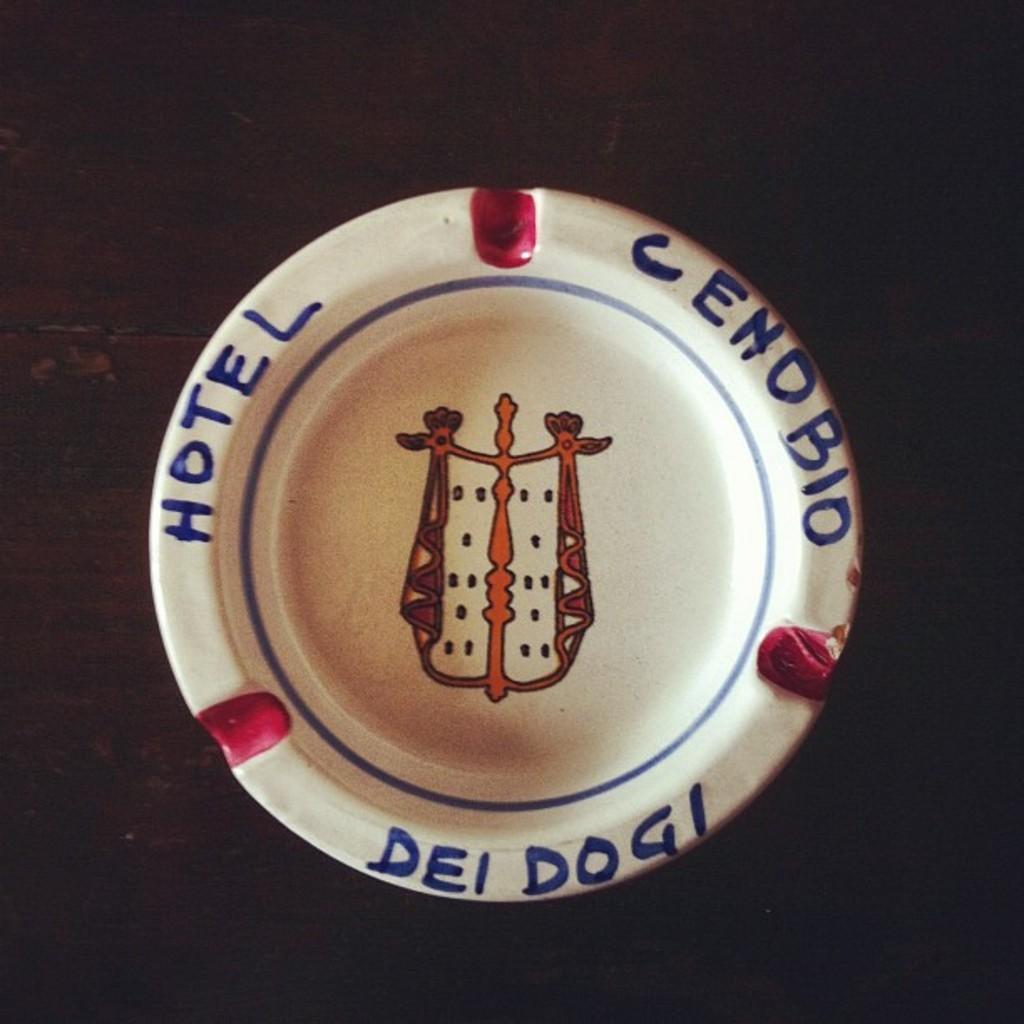What is located on the wooden surface in the image? There is a bowl on the wooden surface in the image. What can be seen on the bowl? There is text and a figure on the bowl. What type of linen is draped over the bowl in the image? There is no linen present in the image; the bowl is placed on a wooden surface. 